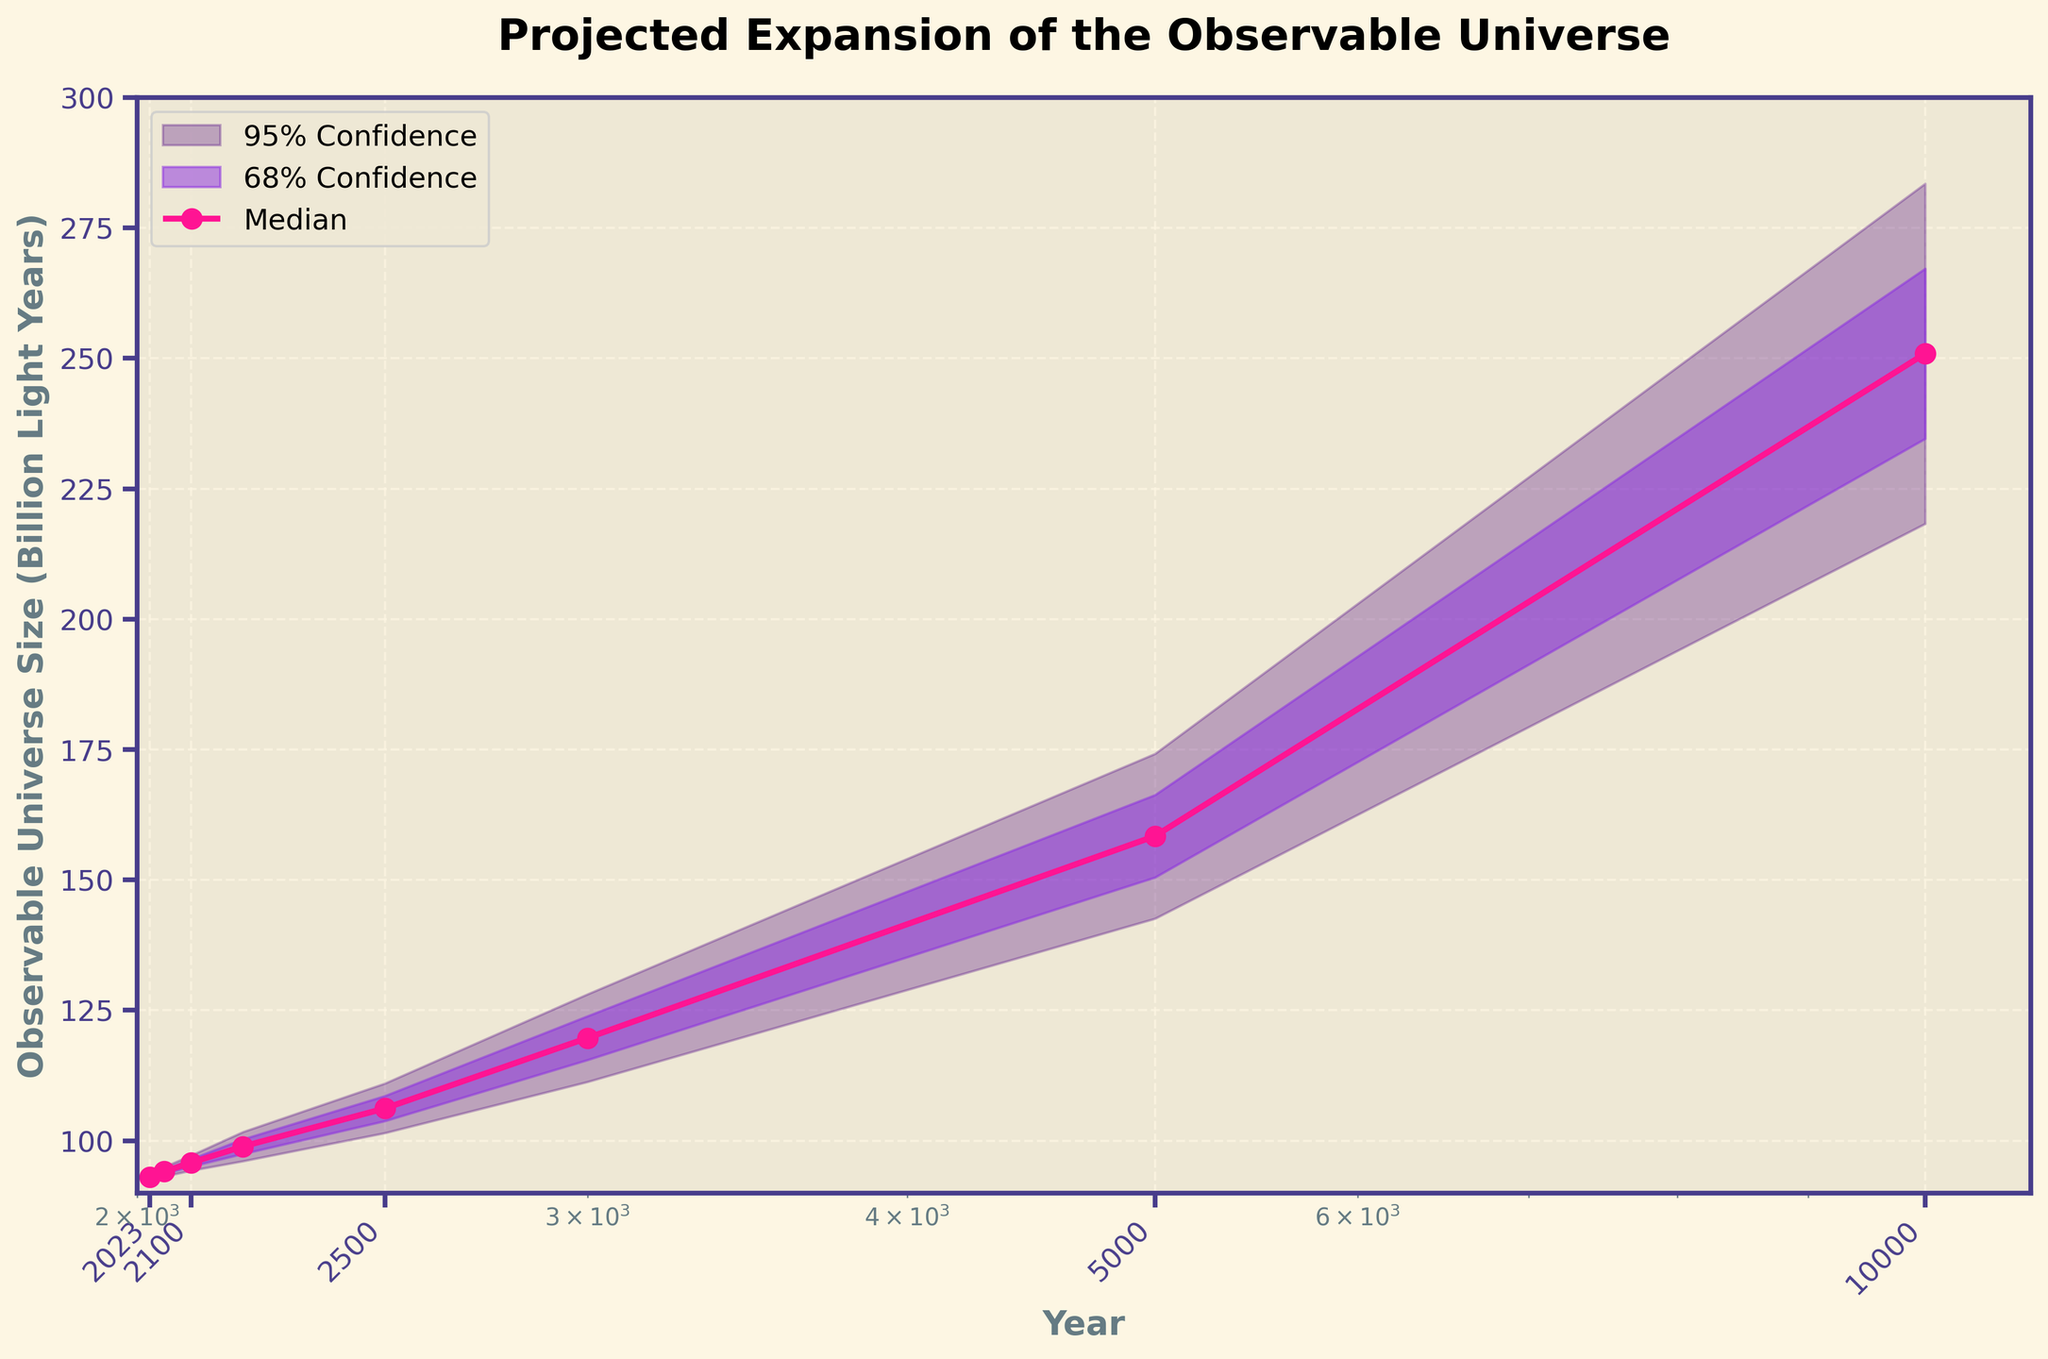What is the title of the figure? The title of the figure is located at the top center and labeled in bold. It provides a summary of the visualized data.
Answer: Projected Expansion of the Observable Universe How many years are represented in the x-axis? The x-axis shows the time points on a logarithmic scale, and the years given in the data are clearly labeled on the axis.
Answer: 8 What does the median value represent in this plot? The median value indicates the central tendency or the most likely expansion size of the observable universe at each given year, as plotted as a distinct curve with markers.
Answer: Central tendency of expansion size What is the observable universe's median size in the year 2100? The plot shows the median size as a line with markers at each year, and the value at 2100 can be read directly from the y-axis at the respective year.
Answer: 95.8 What are the 68% confidence interval boundaries for the year 5000? The 68% confidence interval is shaded, and the boundaries can be read directly from the lower and upper lines of this shaded area at the year 5000. The interval is between 150.5 and 166.3.
Answer: 150.5 to 166.3 How does the median size of the observable universe in 2023 compare to 10000? Compare the median values of both years by noting where they intersect with the y-axis. In 2023 it is 93.0, and in 10000, it is much higher at 250.9.
Answer: Much smaller in 2023 Which year has the largest uncertainty range in the observable universe's expansion projection? Calculate the difference between the Upper_95 and Lower_95 values for each year, and identify the year with the largest range. The largest uncertainty is noted for the year 10000.
Answer: 10000 What is the trend in median expansion size from 2023 to 3000? By observing the median curve, it is clear the median size increases steadily over time, showing a general upward trend.
Answer: Increasing What do the shaded areas represent? The shaded regions in the plot indicate the different confidence intervals; the lighter shaded area represents the 95% confidence interval and the darker shaded area represents the 68% confidence interval. These intervals show the range within which the true size is likely to fall.
Answer: Confidence intervals How will the observable universe size likely change by 2200? Refer to the median value curve at the year 2200 and compare it with earlier years. The median size in 2200 is projected to increase compared to previous years.
Answer: Increase to 98.9 